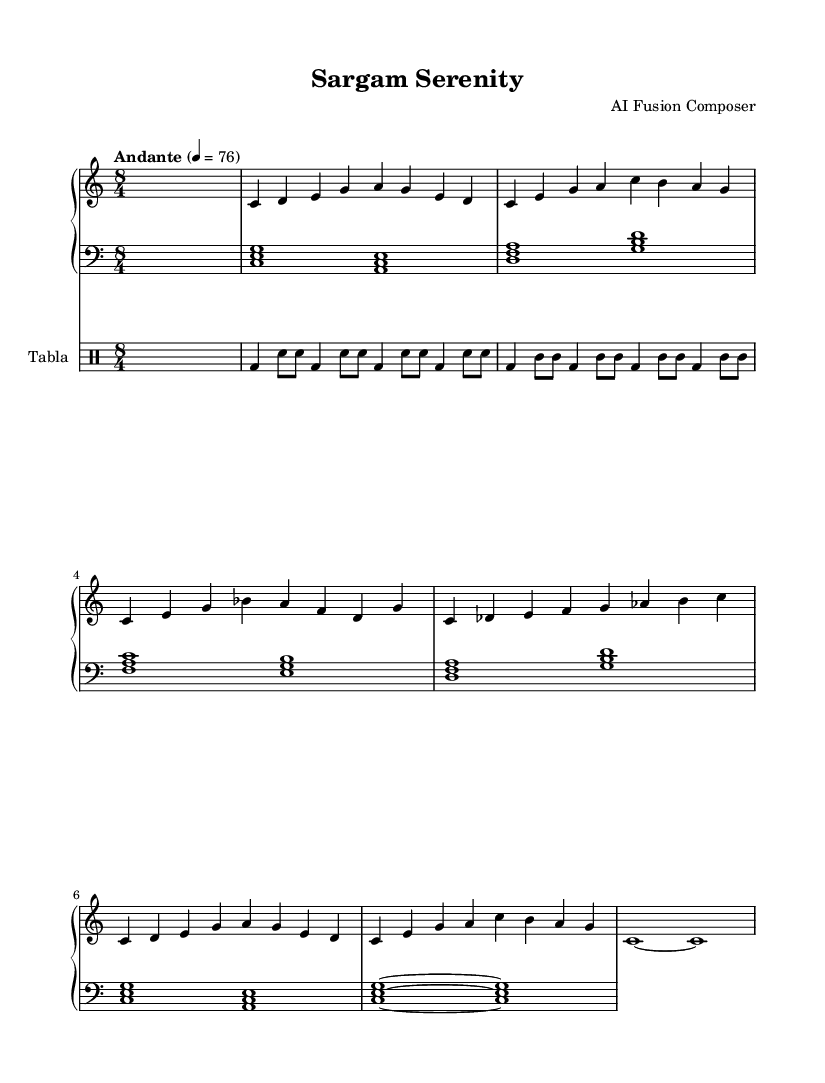What is the key signature of this music? The key signature is C major, which has no sharps or flats indicated in the score.
Answer: C major What is the time signature of this piece? The time signature is 8/4, as seen at the beginning of the score.
Answer: 8/4 What is the tempo marking for this piece? The tempo marking is "Andante," which indicates a moderate pace. It is indicated with a number that corresponds to beats per minute.
Answer: Andante What are the instruments used in this score? The instruments used are Piano and Tabla, stated in the separate staves for each instrument.
Answer: Piano and Tabla How many measures are there in the right hand part? To find the number of measures in the right hand part, I counted the measures shown in the 'rightHand' music section, including those for the Alap, Main Theme, Jazz Interlude, Hindustani Elaboration, Fusion Climax, and Outro. There are five measures.
Answer: Five What is the primary fusion style represented in this music? The score merges Jazz with Hindustani classical elements, seen through the use of jazz phrases and Hindustani elaboration within the structure.
Answer: Jazz-infused Hindustani classical What is the final note in the left hand part? The final note in the left hand part is found at the end of the score and is signified by "c".
Answer: c 